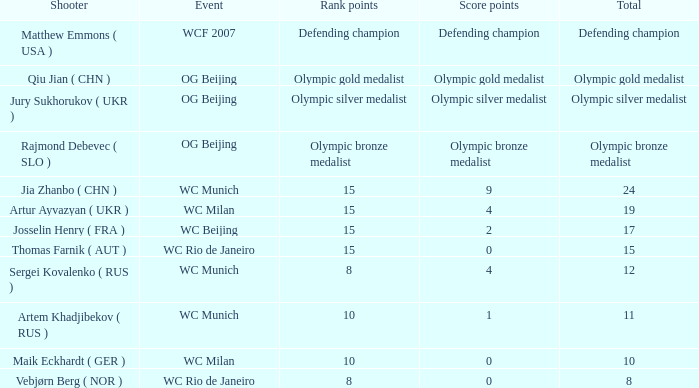Identify the shooter who has 15 rank points and a score of 0. Thomas Farnik ( AUT ). 